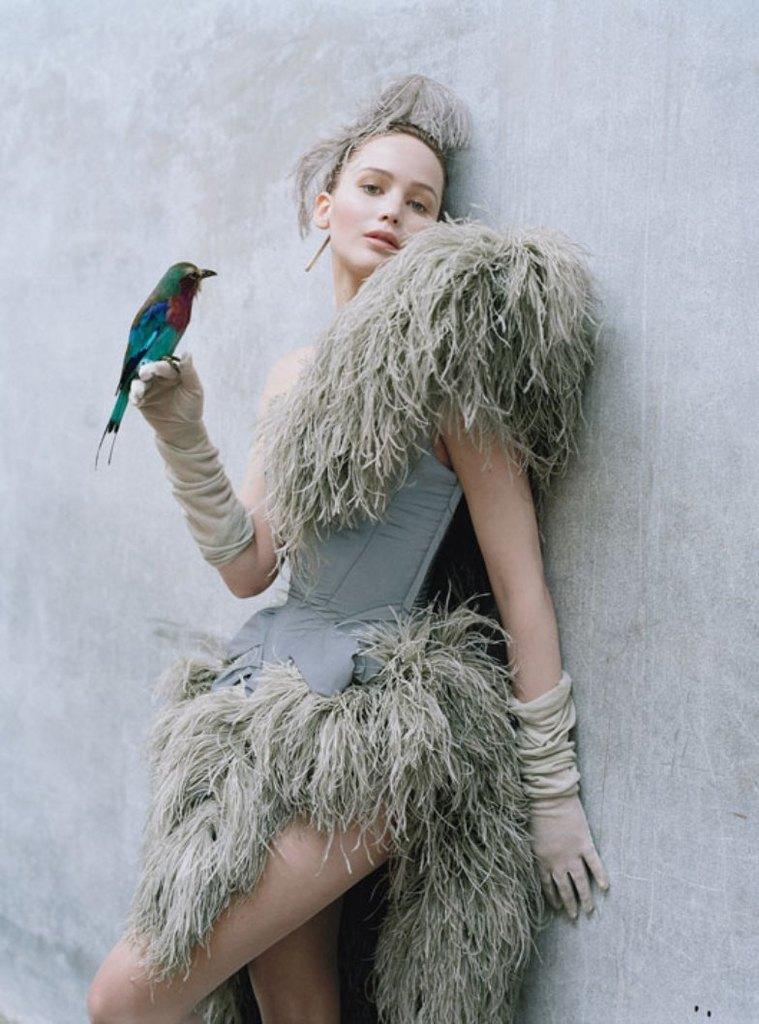Could you give a brief overview of what you see in this image? A beautiful woman is standing near the wall, she wore a dress. There is a bird on her right hand. 